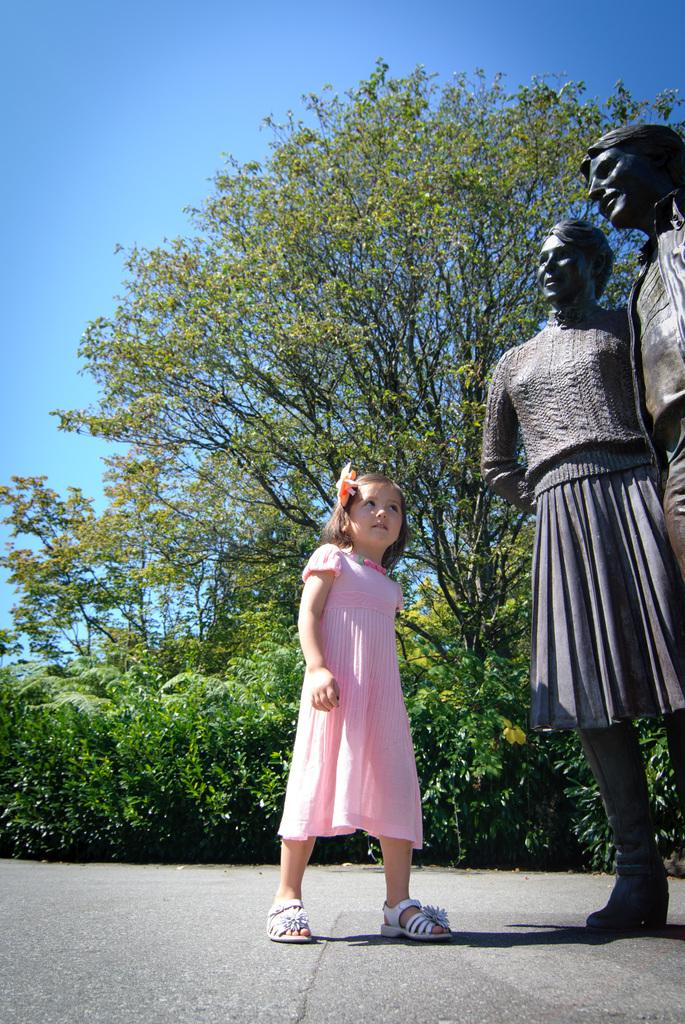What is the girl in the image doing? The girl is standing on the road in the image. What is located near the girl? The girl is near a statue in the image. What can be seen in the background of the image? There are plants, trees, and the sky visible in the background of the image. What type of vase is the girl holding in the image? There is no vase present in the image; the girl is standing near a statue. Can you tell me how many bombs are visible in the image? There are no bombs present in the image; it features a girl standing near a statue with plants, trees, and the sky in the background. 